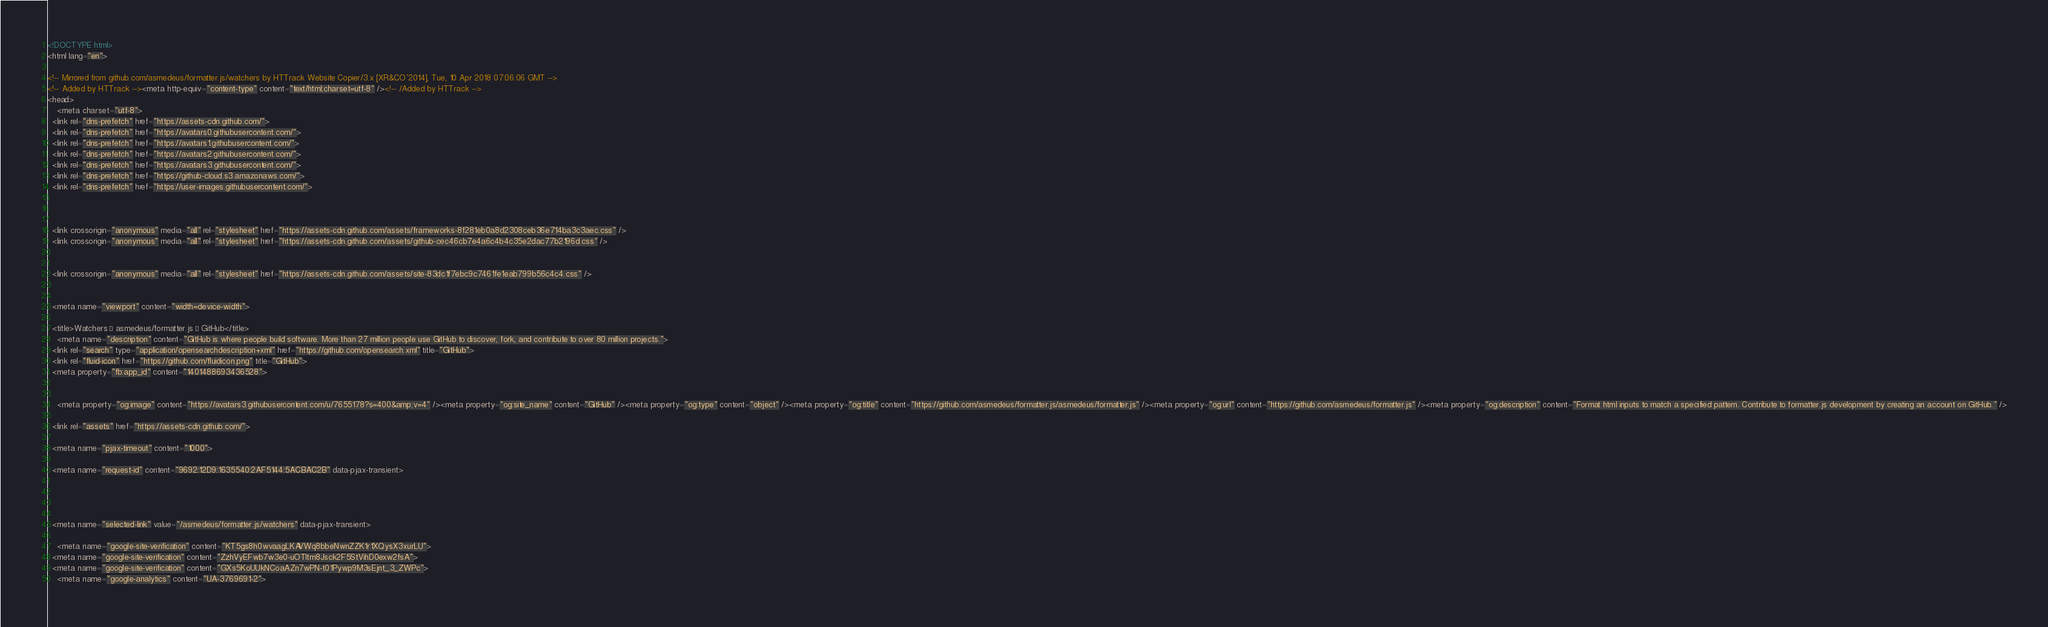<code> <loc_0><loc_0><loc_500><loc_500><_HTML_>





<!DOCTYPE html>
<html lang="en">
  
<!-- Mirrored from github.com/asmedeus/formatter.js/watchers by HTTrack Website Copier/3.x [XR&CO'2014], Tue, 10 Apr 2018 07:06:06 GMT -->
<!-- Added by HTTrack --><meta http-equiv="content-type" content="text/html;charset=utf-8" /><!-- /Added by HTTrack -->
<head>
    <meta charset="utf-8">
  <link rel="dns-prefetch" href="https://assets-cdn.github.com/">
  <link rel="dns-prefetch" href="https://avatars0.githubusercontent.com/">
  <link rel="dns-prefetch" href="https://avatars1.githubusercontent.com/">
  <link rel="dns-prefetch" href="https://avatars2.githubusercontent.com/">
  <link rel="dns-prefetch" href="https://avatars3.githubusercontent.com/">
  <link rel="dns-prefetch" href="https://github-cloud.s3.amazonaws.com/">
  <link rel="dns-prefetch" href="https://user-images.githubusercontent.com/">



  <link crossorigin="anonymous" media="all" rel="stylesheet" href="https://assets-cdn.github.com/assets/frameworks-8f281eb0a8d2308ceb36e714ba3c3aec.css" />
  <link crossorigin="anonymous" media="all" rel="stylesheet" href="https://assets-cdn.github.com/assets/github-cec46cb7e4a6c4b4c35e2dac77b2196d.css" />
  
  
  <link crossorigin="anonymous" media="all" rel="stylesheet" href="https://assets-cdn.github.com/assets/site-83dc1f7ebc9c7461fe1eab799b56c4c4.css" />
  

  <meta name="viewport" content="width=device-width">
  
  <title>Watchers · asmedeus/formatter.js · GitHub</title>
    <meta name="description" content="GitHub is where people build software. More than 27 million people use GitHub to discover, fork, and contribute to over 80 million projects.">
  <link rel="search" type="application/opensearchdescription+xml" href="https://github.com/opensearch.xml" title="GitHub">
  <link rel="fluid-icon" href="https://github.com/fluidicon.png" title="GitHub">
  <meta property="fb:app_id" content="1401488693436528">

    
    <meta property="og:image" content="https://avatars3.githubusercontent.com/u/7655178?s=400&amp;v=4" /><meta property="og:site_name" content="GitHub" /><meta property="og:type" content="object" /><meta property="og:title" content="https://github.com/asmedeus/formatter.js/asmedeus/formatter.js" /><meta property="og:url" content="https://github.com/asmedeus/formatter.js" /><meta property="og:description" content="Format html inputs to match a specified pattern. Contribute to formatter.js development by creating an account on GitHub." />

  <link rel="assets" href="https://assets-cdn.github.com/">
  
  <meta name="pjax-timeout" content="1000">
  
  <meta name="request-id" content="9692:12D9:1635540:2AF5144:5ACBAC2B" data-pjax-transient>


  

  <meta name="selected-link" value="/asmedeus/formatter.js/watchers" data-pjax-transient>

    <meta name="google-site-verification" content="KT5gs8h0wvaagLKAVWq8bbeNwnZZK1r1XQysX3xurLU">
  <meta name="google-site-verification" content="ZzhVyEFwb7w3e0-uOTltm8Jsck2F5StVihD0exw2fsA">
  <meta name="google-site-verification" content="GXs5KoUUkNCoaAZn7wPN-t01Pywp9M3sEjnt_3_ZWPc">
    <meta name="google-analytics" content="UA-3769691-2">
</code> 